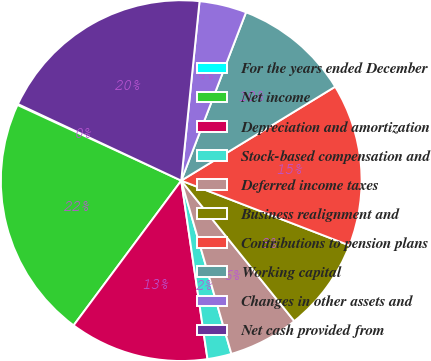<chart> <loc_0><loc_0><loc_500><loc_500><pie_chart><fcel>For the years ended December<fcel>Net income<fcel>Depreciation and amortization<fcel>Stock-based compensation and<fcel>Deferred income taxes<fcel>Business realignment and<fcel>Contributions to pension plans<fcel>Working capital<fcel>Changes in other assets and<fcel>Net cash provided from<nl><fcel>0.09%<fcel>21.71%<fcel>12.5%<fcel>2.16%<fcel>6.3%<fcel>8.36%<fcel>14.57%<fcel>10.43%<fcel>4.23%<fcel>19.64%<nl></chart> 